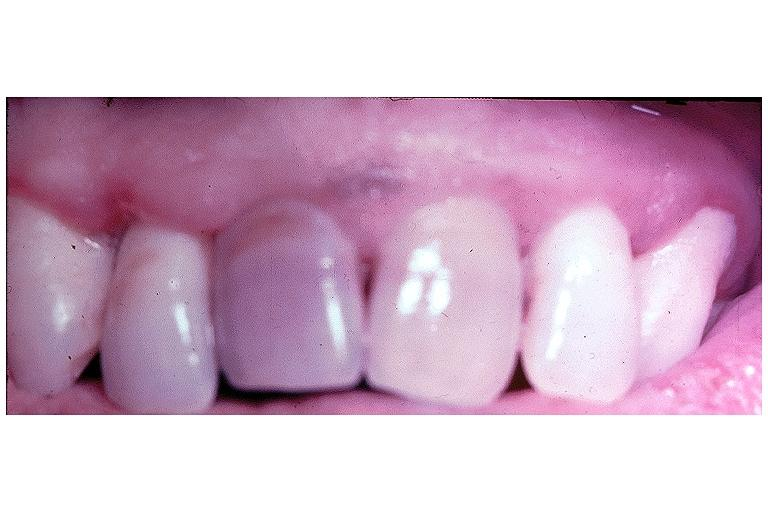where is this?
Answer the question using a single word or phrase. Oral 